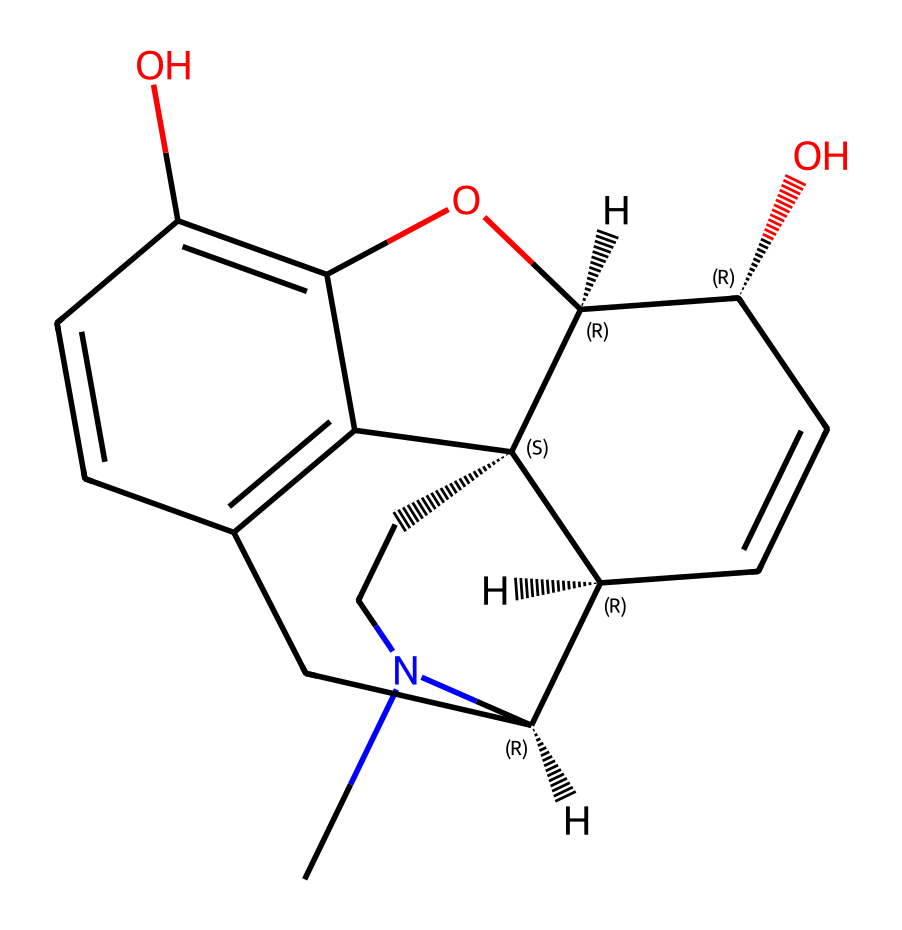What is the molecular formula of morphine based on its structure? To derive the molecular formula, count the number of each type of atom present in the SMILES representation. The structure includes 17 carbon (C) atoms, 19 hydrogen (H) atoms, 3 oxygen (O) atoms, and 1 nitrogen (N) atom. Therefore, the molecular formula is C17H19N3O3.
Answer: C17H19N3O3 How many rings are present in the structure of morphine? By analyzing the rings in the chemical structure derived from the SMILES representation, it can be observed that there are five distinct rings present. Thus, the total number of rings is five.
Answer: five Identify the functional groups present in morphine. Examining the structure reveals multiple functional groups, specifically phenolic (the -OH groups on the aromatic rings) and amine (the nitrogen-containing group). These are key in morphine’s properties.
Answer: phenolic and amine What is the stereochemistry of morphine at the chiral centers? The SMILES representation includes '@', which indicates stereocenters. Morphine has several chiral centers with specific configurations (S or R), which are important for its biological activity. The stereochemistry is S at C2 and C3, R at C6.
Answer: S at C2 and C3, R at C6 Does the morphine structure indicate solubility in water? The presence of hydroxyl (-OH) groups increases hydrogen bonding capacity, suggesting that morphine has some level of polarity and hence is soluble in water to a certain extent, although its bulky structure may reduce overall solubility.
Answer: somewhat soluble What part of the morphine structure is primarily responsible for its analgesic properties? The phenolic and the nitrogen-containing structural features are crucial for morphine’s interaction with opioid receptors in the body. These components allow morphine to effectively act as an analgesic.
Answer: phenolic and nitrogen groups 